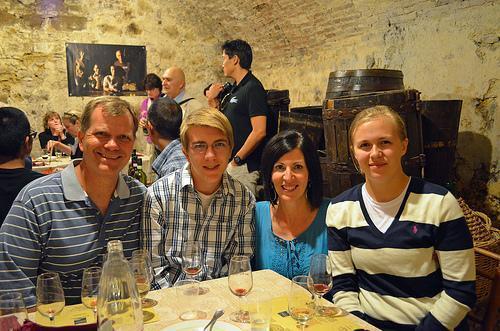How many people are smiling?
Give a very brief answer. 4. 